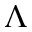Convert formula to latex. <formula><loc_0><loc_0><loc_500><loc_500>\Lambda</formula> 